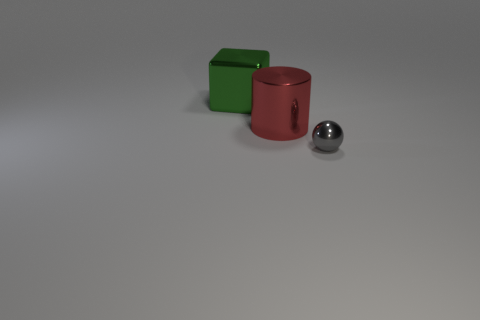Subtract all purple balls. Subtract all yellow cylinders. How many balls are left? 1 Subtract all cyan cylinders. How many green spheres are left? 0 Add 2 greens. How many tiny grays exist? 0 Subtract all blue things. Subtract all big metallic cylinders. How many objects are left? 2 Add 1 gray spheres. How many gray spheres are left? 2 Add 3 large gray metallic cubes. How many large gray metallic cubes exist? 3 Add 1 large objects. How many objects exist? 4 Subtract 0 cyan blocks. How many objects are left? 3 Subtract all blocks. How many objects are left? 2 Subtract 1 cylinders. How many cylinders are left? 0 